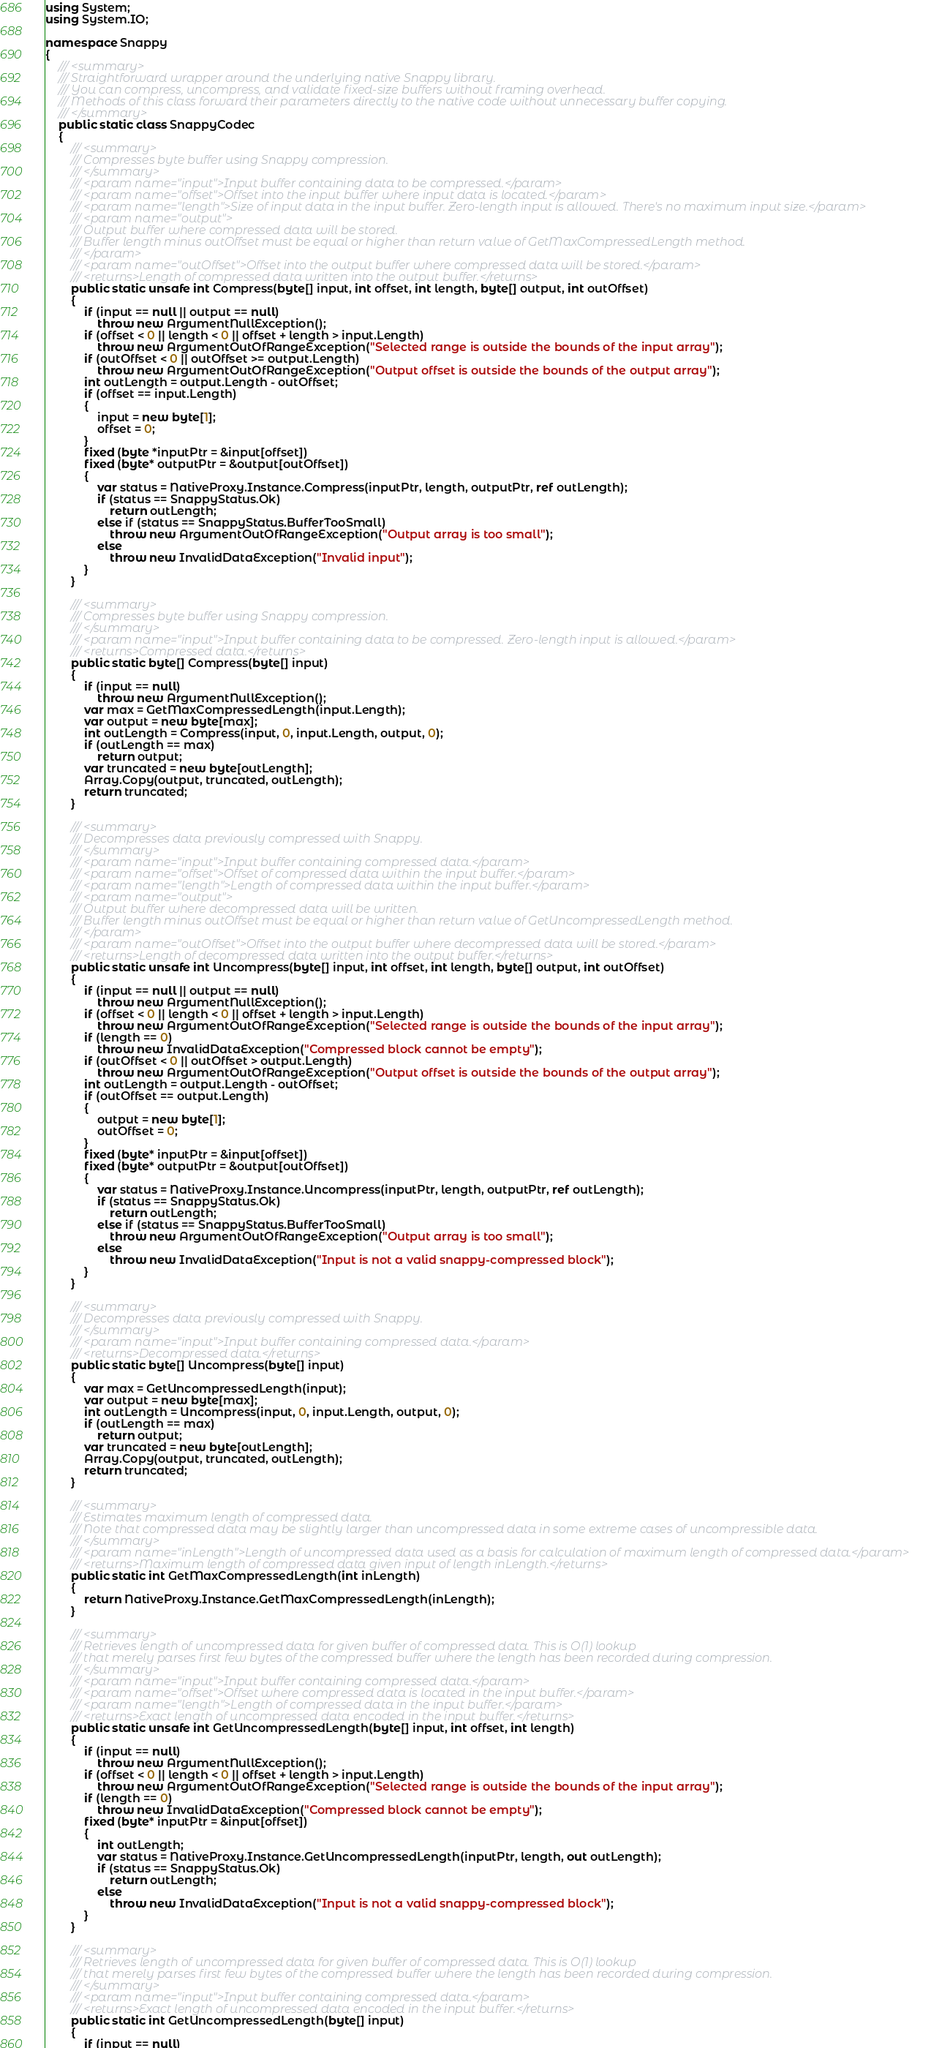<code> <loc_0><loc_0><loc_500><loc_500><_C#_>using System;
using System.IO;

namespace Snappy
{
    /// <summary>
    /// Straightforward wrapper around the underlying native Snappy library.
    /// You can compress, uncompress, and validate fixed-size buffers without framing overhead.
    /// Methods of this class forward their parameters directly to the native code without unnecessary buffer copying.
    /// </summary>
    public static class SnappyCodec
    {
        /// <summary>
        /// Compresses byte buffer using Snappy compression.
        /// </summary>
        /// <param name="input">Input buffer containing data to be compressed.</param>
        /// <param name="offset">Offset into the input buffer where input data is located.</param>
        /// <param name="length">Size of input data in the input buffer. Zero-length input is allowed. There's no maximum input size.</param>
        /// <param name="output">
        /// Output buffer where compressed data will be stored.
        /// Buffer length minus outOffset must be equal or higher than return value of GetMaxCompressedLength method.
        /// </param>
        /// <param name="outOffset">Offset into the output buffer where compressed data will be stored.</param>
        /// <returns>Length of compressed data written into the output buffer.</returns>
        public static unsafe int Compress(byte[] input, int offset, int length, byte[] output, int outOffset)
        {
            if (input == null || output == null)
                throw new ArgumentNullException();
            if (offset < 0 || length < 0 || offset + length > input.Length)
                throw new ArgumentOutOfRangeException("Selected range is outside the bounds of the input array");
            if (outOffset < 0 || outOffset >= output.Length)
                throw new ArgumentOutOfRangeException("Output offset is outside the bounds of the output array");
            int outLength = output.Length - outOffset;
            if (offset == input.Length)
            {
                input = new byte[1];
                offset = 0;
            }
            fixed (byte *inputPtr = &input[offset])
            fixed (byte* outputPtr = &output[outOffset])
            {
                var status = NativeProxy.Instance.Compress(inputPtr, length, outputPtr, ref outLength);
                if (status == SnappyStatus.Ok)
                    return outLength;
                else if (status == SnappyStatus.BufferTooSmall)
                    throw new ArgumentOutOfRangeException("Output array is too small");
                else
                    throw new InvalidDataException("Invalid input");
            }
        }

        /// <summary>
        /// Compresses byte buffer using Snappy compression.
        /// </summary>
        /// <param name="input">Input buffer containing data to be compressed. Zero-length input is allowed.</param>
        /// <returns>Compressed data.</returns>
        public static byte[] Compress(byte[] input)
        {
            if (input == null)
                throw new ArgumentNullException();
            var max = GetMaxCompressedLength(input.Length);
            var output = new byte[max];
            int outLength = Compress(input, 0, input.Length, output, 0);
            if (outLength == max)
                return output;
            var truncated = new byte[outLength];
            Array.Copy(output, truncated, outLength);
            return truncated;
        }

        /// <summary>
        /// Decompresses data previously compressed with Snappy.
        /// </summary>
        /// <param name="input">Input buffer containing compressed data.</param>
        /// <param name="offset">Offset of compressed data within the input buffer.</param>
        /// <param name="length">Length of compressed data within the input buffer.</param>
        /// <param name="output">
        /// Output buffer where decompressed data will be written.
        /// Buffer length minus outOffset must be equal or higher than return value of GetUncompressedLength method.
        /// </param>
        /// <param name="outOffset">Offset into the output buffer where decompressed data will be stored.</param>
        /// <returns>Length of decompressed data written into the output buffer.</returns>
        public static unsafe int Uncompress(byte[] input, int offset, int length, byte[] output, int outOffset)
        {
            if (input == null || output == null)
                throw new ArgumentNullException();
            if (offset < 0 || length < 0 || offset + length > input.Length)
                throw new ArgumentOutOfRangeException("Selected range is outside the bounds of the input array");
            if (length == 0)
                throw new InvalidDataException("Compressed block cannot be empty");
            if (outOffset < 0 || outOffset > output.Length)
                throw new ArgumentOutOfRangeException("Output offset is outside the bounds of the output array");
            int outLength = output.Length - outOffset;
            if (outOffset == output.Length)
            {
                output = new byte[1];
                outOffset = 0;
            }
            fixed (byte* inputPtr = &input[offset])
            fixed (byte* outputPtr = &output[outOffset])
            {
                var status = NativeProxy.Instance.Uncompress(inputPtr, length, outputPtr, ref outLength);
                if (status == SnappyStatus.Ok)
                    return outLength;
                else if (status == SnappyStatus.BufferTooSmall)
                    throw new ArgumentOutOfRangeException("Output array is too small");
                else
                    throw new InvalidDataException("Input is not a valid snappy-compressed block");
            }
        }

        /// <summary>
        /// Decompresses data previously compressed with Snappy.
        /// </summary>
        /// <param name="input">Input buffer containing compressed data.</param>
        /// <returns>Decompressed data.</returns>
        public static byte[] Uncompress(byte[] input)
        {
            var max = GetUncompressedLength(input);
            var output = new byte[max];
            int outLength = Uncompress(input, 0, input.Length, output, 0);
            if (outLength == max)
                return output;
            var truncated = new byte[outLength];
            Array.Copy(output, truncated, outLength);
            return truncated;
        }

        /// <summary>
        /// Estimates maximum length of compressed data.
        /// Note that compressed data may be slightly larger than uncompressed data in some extreme cases of uncompressible data.
        /// </summary>
        /// <param name="inLength">Length of uncompressed data used as a basis for calculation of maximum length of compressed data.</param>
        /// <returns>Maximum length of compressed data given input of length inLength.</returns>
        public static int GetMaxCompressedLength(int inLength)
        {
            return NativeProxy.Instance.GetMaxCompressedLength(inLength);
        }

        /// <summary>
        /// Retrieves length of uncompressed data for given buffer of compressed data. This is O(1) lookup
        /// that merely parses first few bytes of the compressed buffer where the length has been recorded during compression.
        /// </summary>
        /// <param name="input">Input buffer containing compressed data.</param>
        /// <param name="offset">Offset where compressed data is located in the input buffer.</param>
        /// <param name="length">Length of compressed data in the input buffer.</param>
        /// <returns>Exact length of uncompressed data encoded in the input buffer.</returns>
        public static unsafe int GetUncompressedLength(byte[] input, int offset, int length)
        {
            if (input == null)
                throw new ArgumentNullException();
            if (offset < 0 || length < 0 || offset + length > input.Length)
                throw new ArgumentOutOfRangeException("Selected range is outside the bounds of the input array");
            if (length == 0)
                throw new InvalidDataException("Compressed block cannot be empty");
            fixed (byte* inputPtr = &input[offset])
            {
                int outLength;
                var status = NativeProxy.Instance.GetUncompressedLength(inputPtr, length, out outLength);
                if (status == SnappyStatus.Ok)
                    return outLength;
                else
                    throw new InvalidDataException("Input is not a valid snappy-compressed block");
            }
        }

        /// <summary>
        /// Retrieves length of uncompressed data for given buffer of compressed data. This is O(1) lookup
        /// that merely parses first few bytes of the compressed buffer where the length has been recorded during compression.
        /// </summary>
        /// <param name="input">Input buffer containing compressed data.</param>
        /// <returns>Exact length of uncompressed data encoded in the input buffer.</returns>
        public static int GetUncompressedLength(byte[] input)
        {
            if (input == null)</code> 